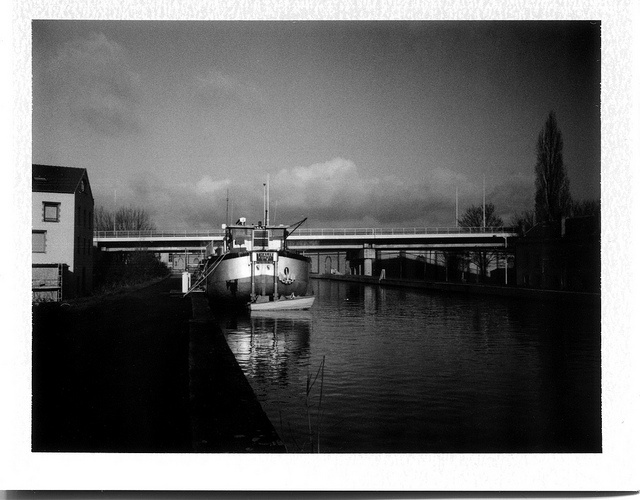Describe the objects in this image and their specific colors. I can see a boat in white, black, gray, darkgray, and lightgray tones in this image. 